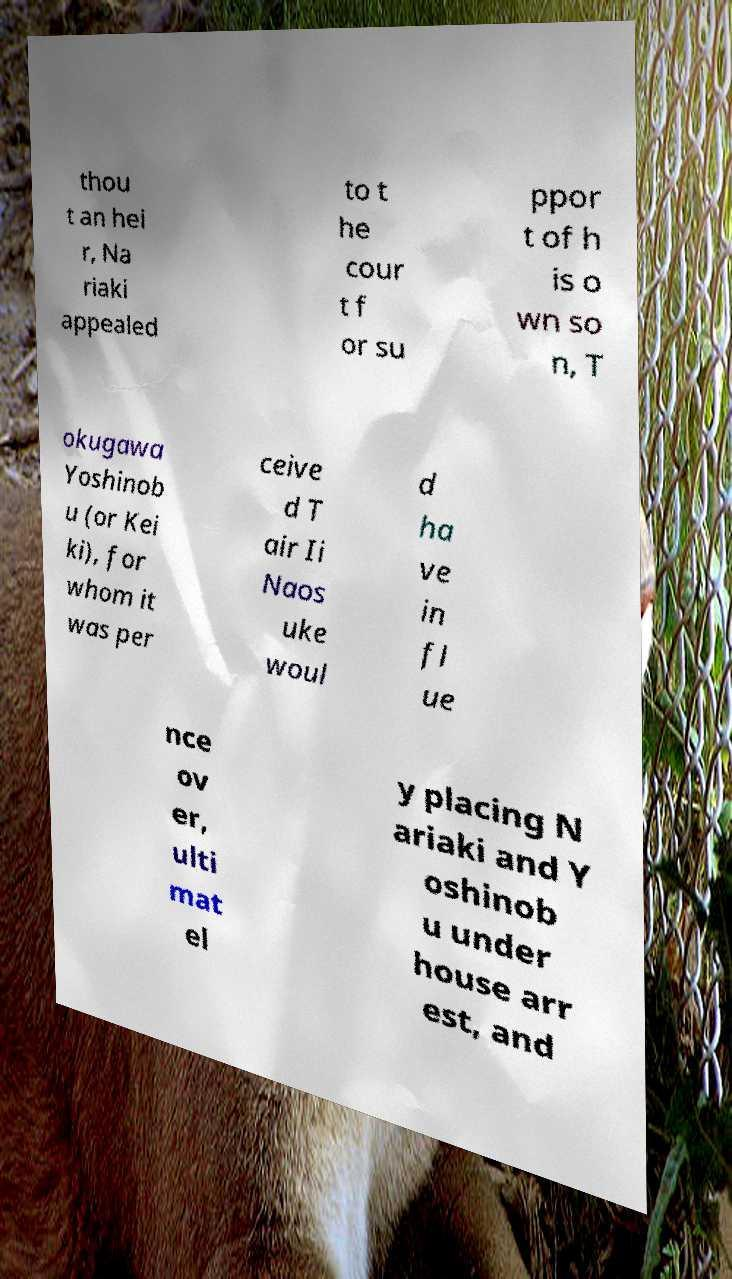I need the written content from this picture converted into text. Can you do that? thou t an hei r, Na riaki appealed to t he cour t f or su ppor t of h is o wn so n, T okugawa Yoshinob u (or Kei ki), for whom it was per ceive d T air Ii Naos uke woul d ha ve in fl ue nce ov er, ulti mat el y placing N ariaki and Y oshinob u under house arr est, and 